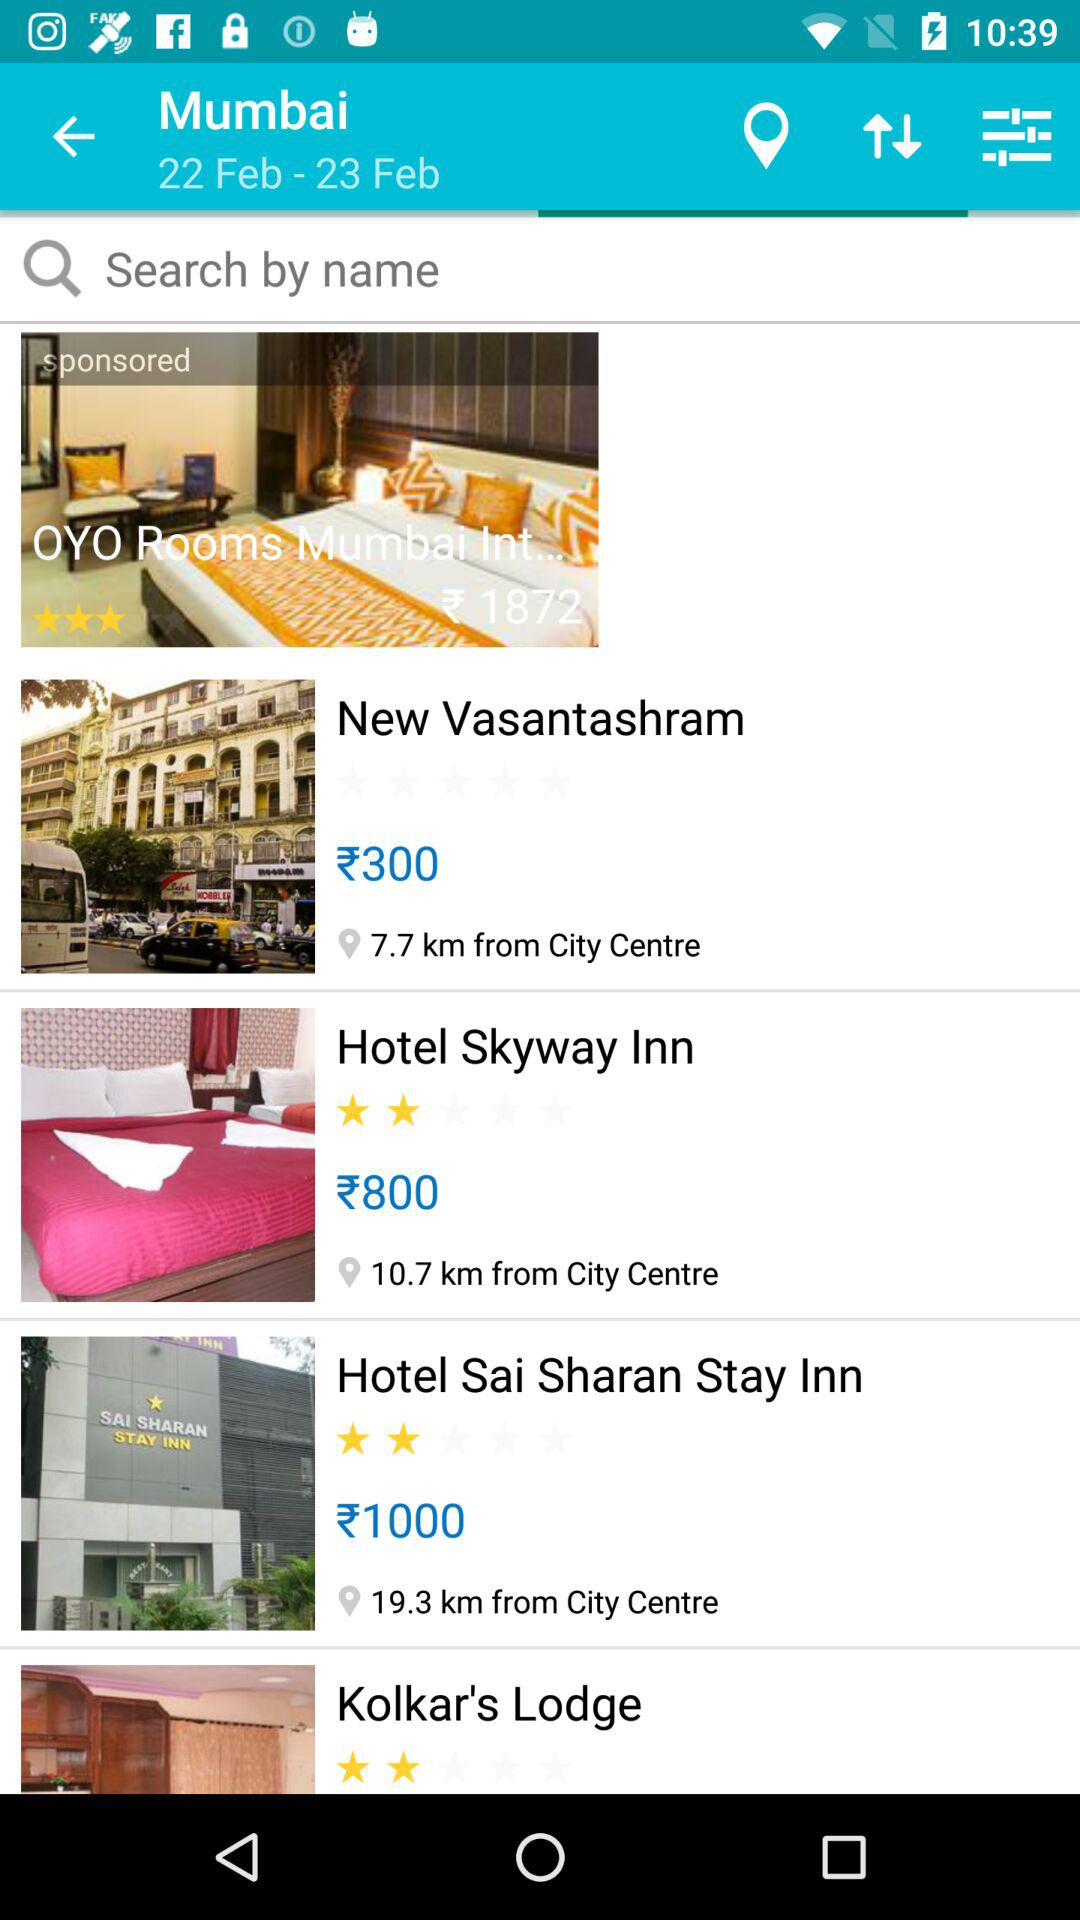How many hotels are located more than 10 km from the city centre?
Answer the question using a single word or phrase. 2 